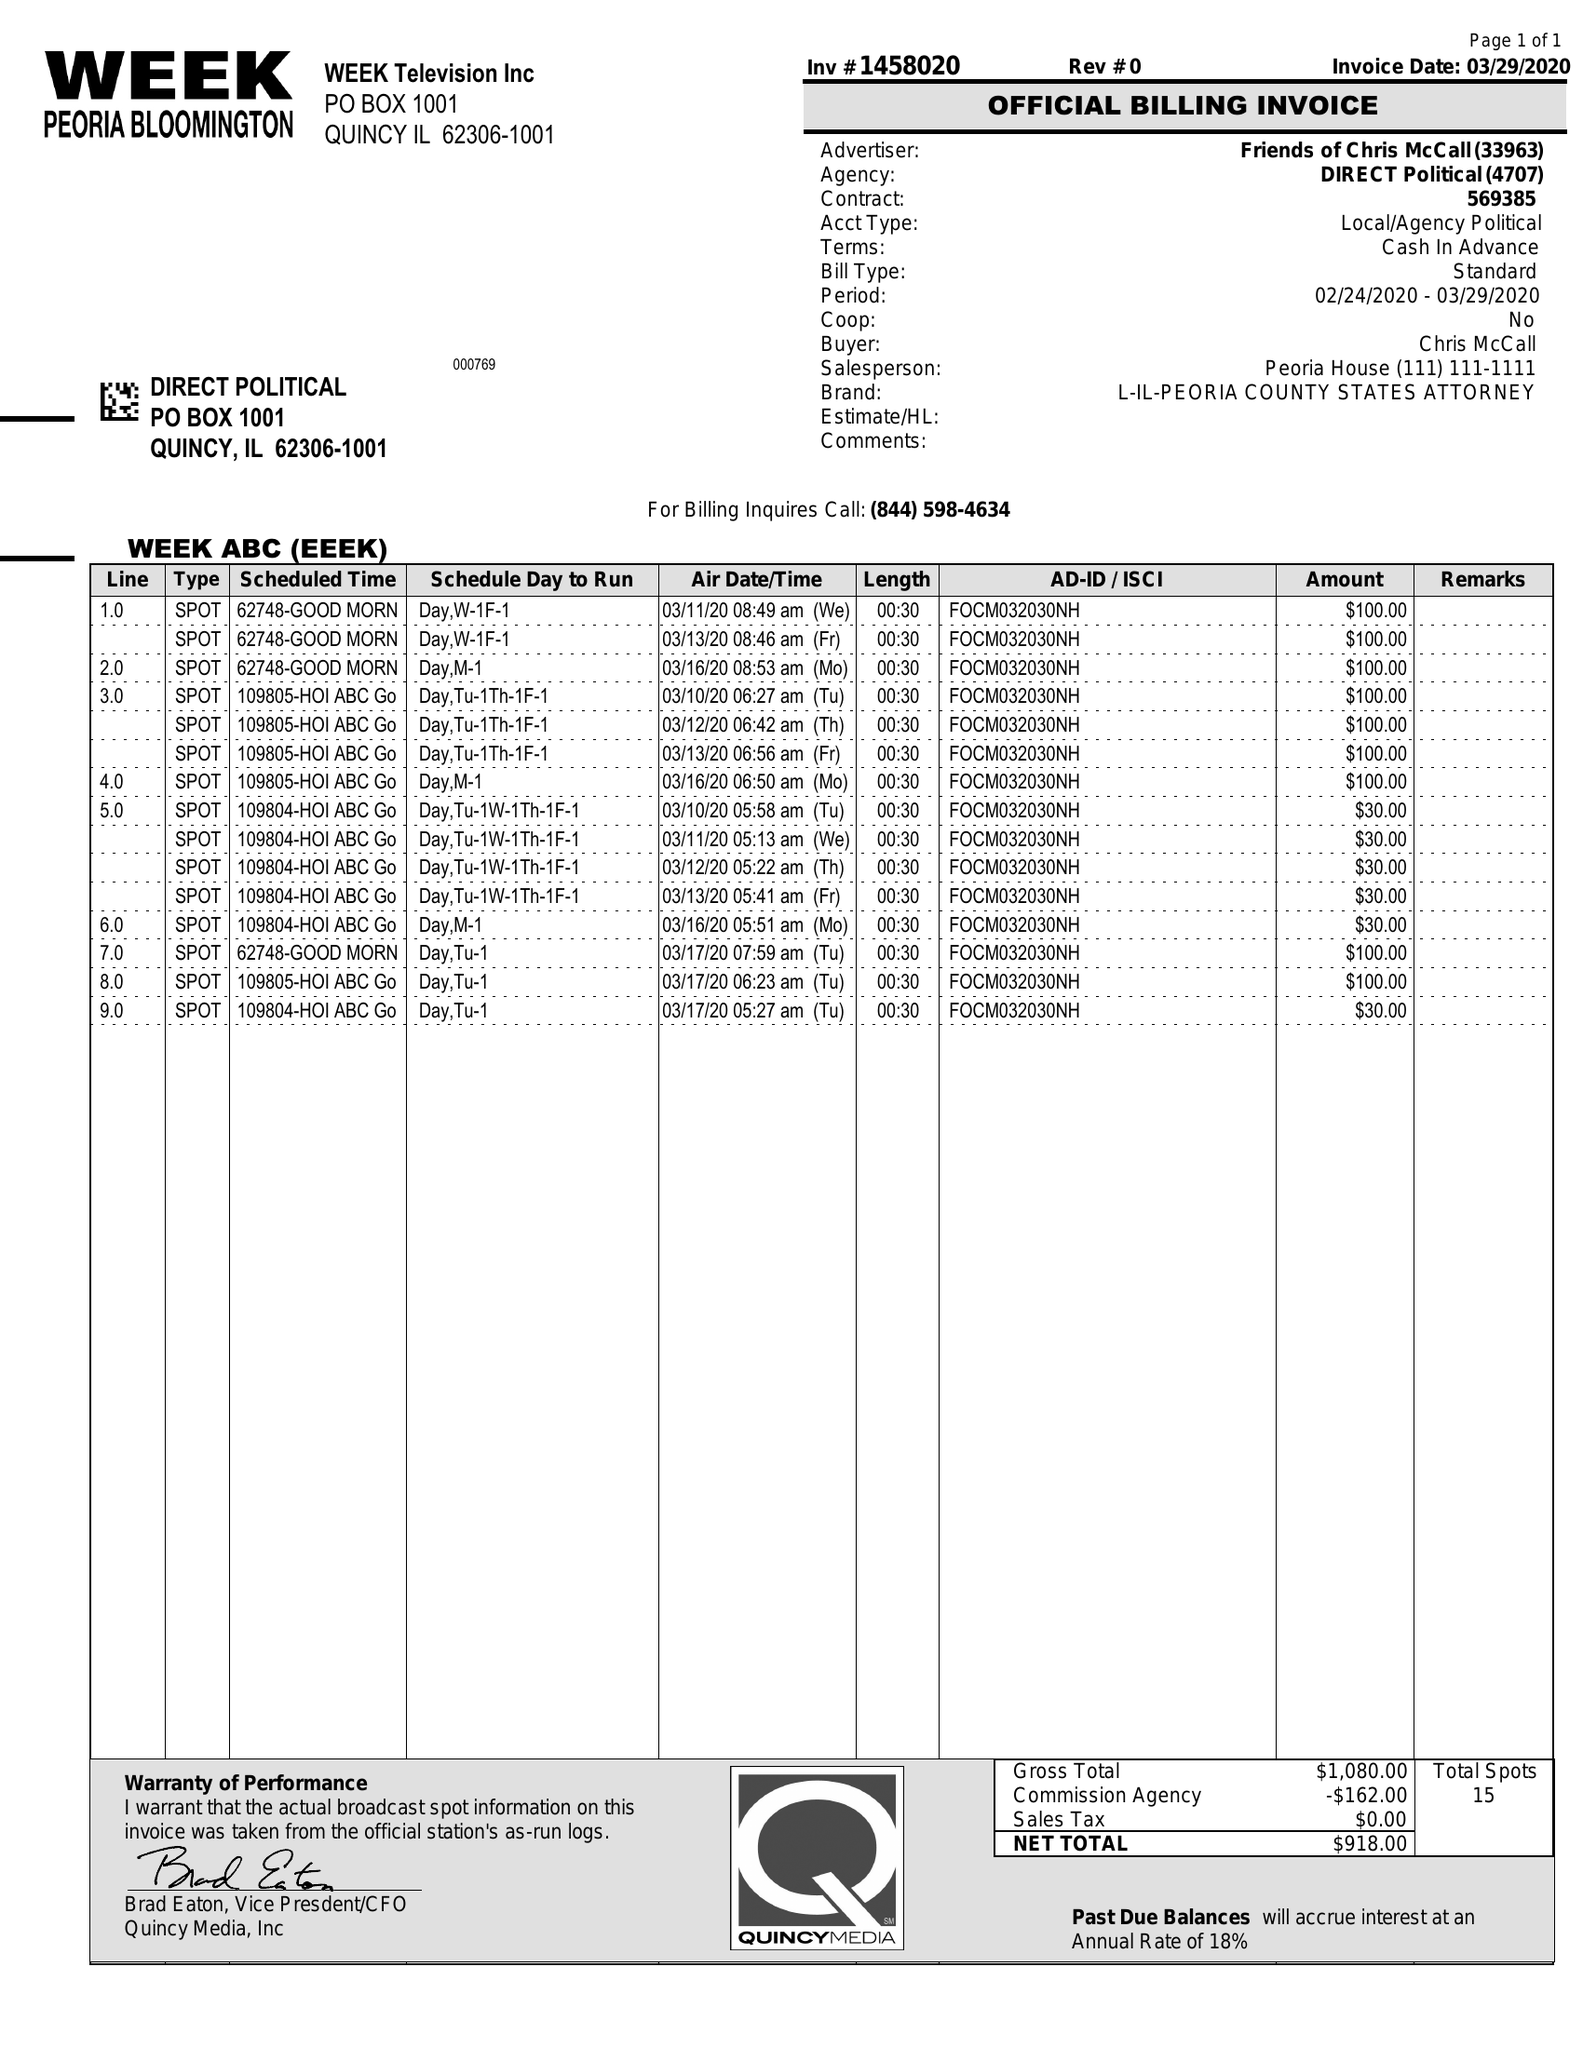What is the value for the contract_num?
Answer the question using a single word or phrase. 1458020 